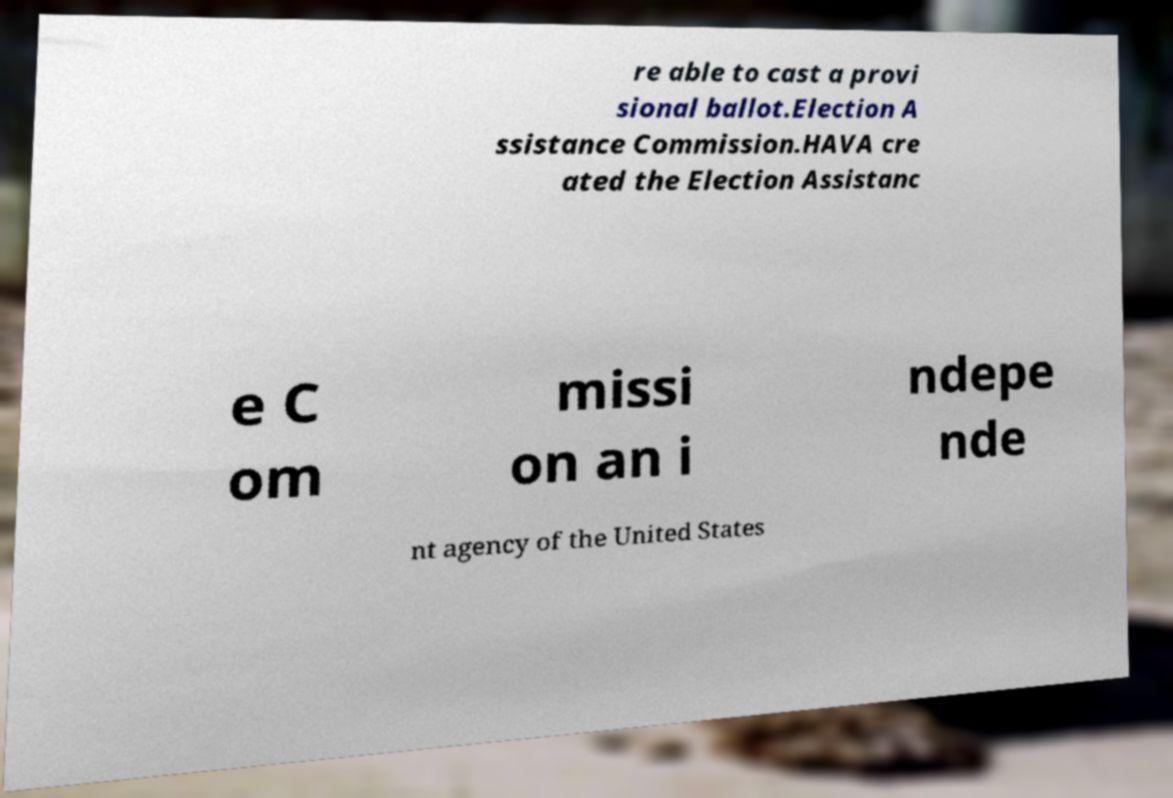What messages or text are displayed in this image? I need them in a readable, typed format. re able to cast a provi sional ballot.Election A ssistance Commission.HAVA cre ated the Election Assistanc e C om missi on an i ndepe nde nt agency of the United States 